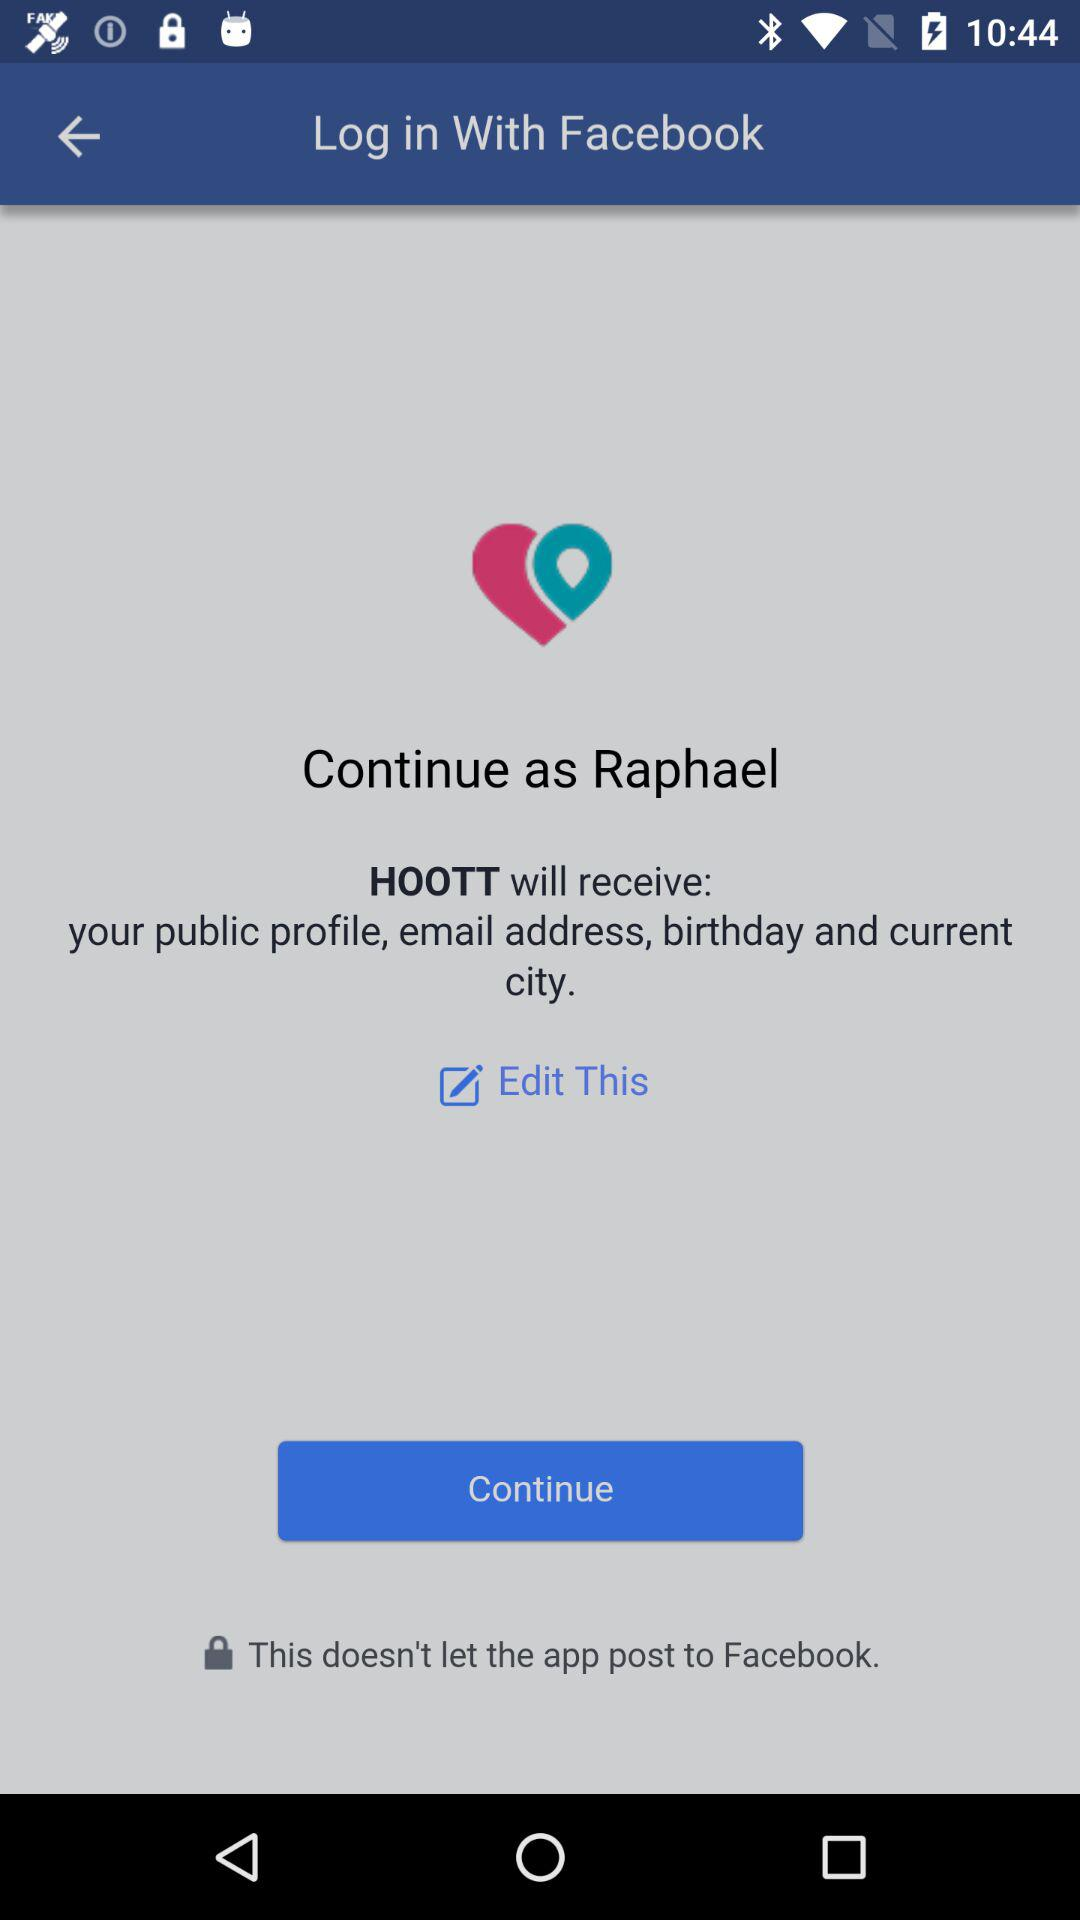What application are we accessing? We are accessing "HOOTT". 